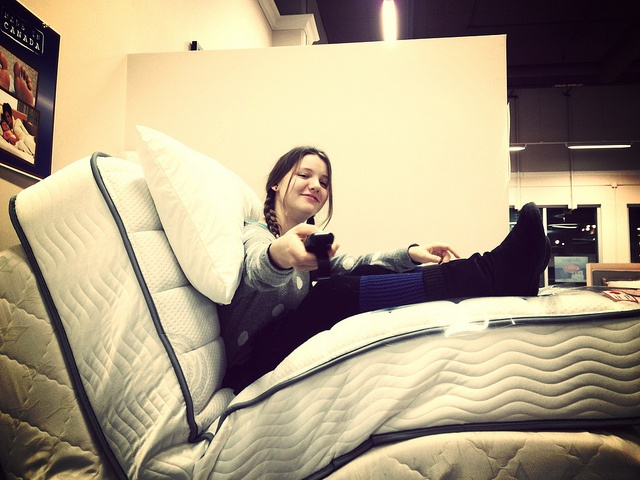Describe the objects in this image and their specific colors. I can see bed in black, beige, lightyellow, and gray tones, people in black, gray, tan, and navy tones, tv in black, darkgray, and gray tones, and remote in black, gray, and purple tones in this image. 